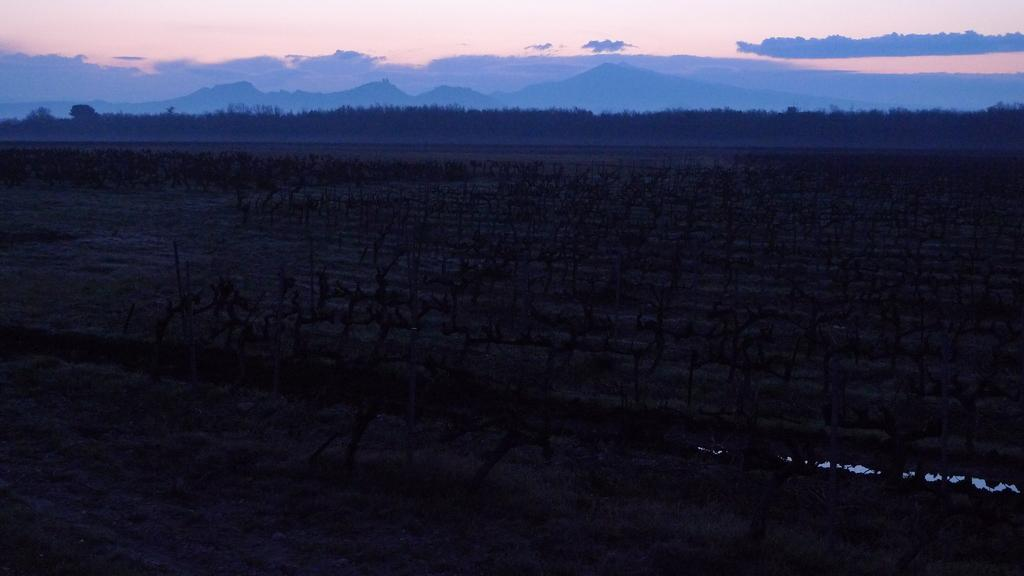What type of landscape is visible at the bottom side of the image? There is a field at the bottom side of the image. What can be seen at the top side of the image? There is sky at the top side of the image. What type of chin can be seen in the image? There is no chin present in the image. Is there a gun visible in the image? No, there is no gun present in the image. 